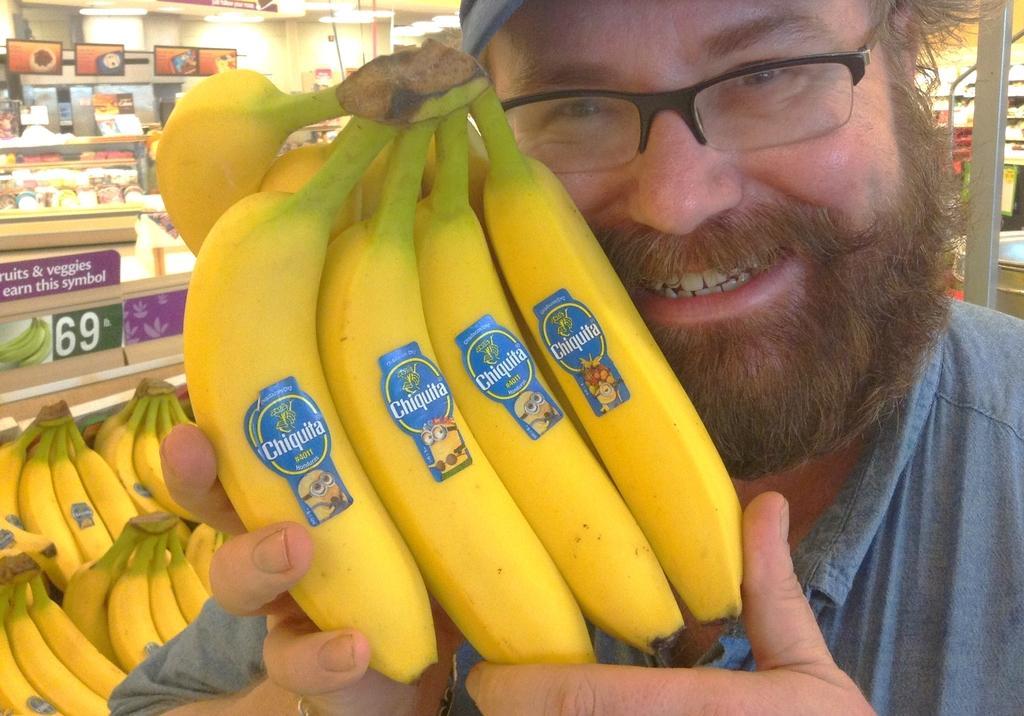Can you describe this image briefly? In this picture there is a man in the center of the image, by holding bananas in his hand and there is a rack in the background area of the image, which contains fruits and other items. 